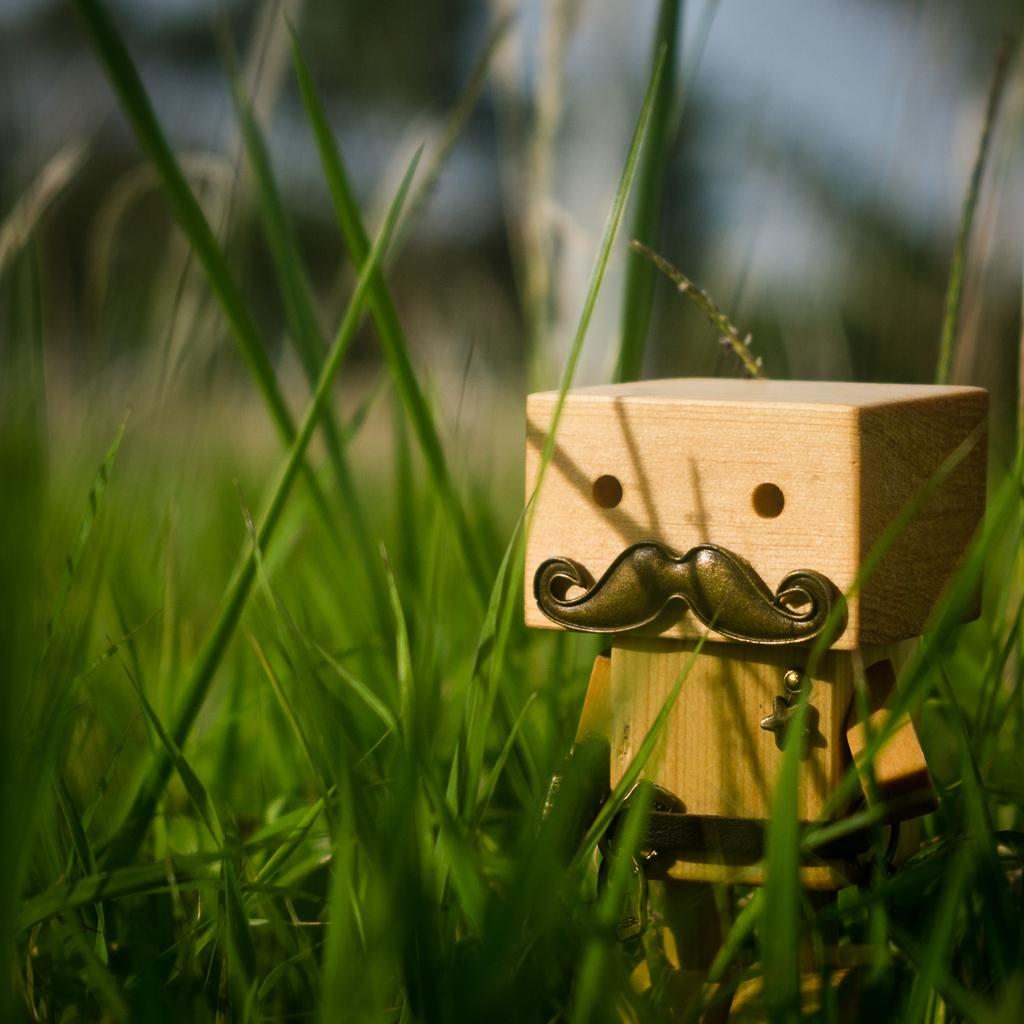What object can be seen in the image? There is a toy in the image. Where is the toy located in the image? The toy is on the right side of the image. What type of environment is the toy in? The toy is on a grassland. How many girls are playing with the toy in the image? There are no girls present in the image; it only features a toy on a grassland. What type of pipe can be seen connected to the toy in the image? There is no pipe connected to the toy in the image. 